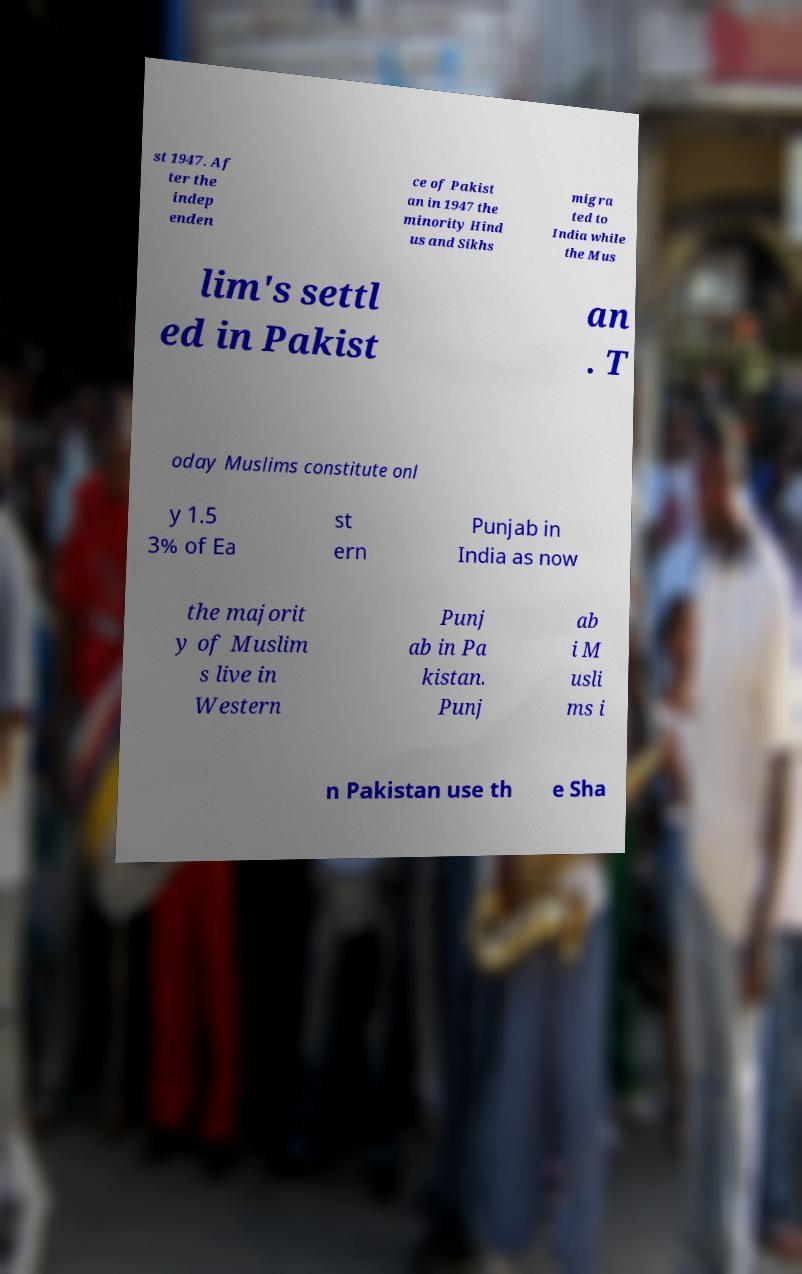What messages or text are displayed in this image? I need them in a readable, typed format. st 1947. Af ter the indep enden ce of Pakist an in 1947 the minority Hind us and Sikhs migra ted to India while the Mus lim's settl ed in Pakist an . T oday Muslims constitute onl y 1.5 3% of Ea st ern Punjab in India as now the majorit y of Muslim s live in Western Punj ab in Pa kistan. Punj ab i M usli ms i n Pakistan use th e Sha 